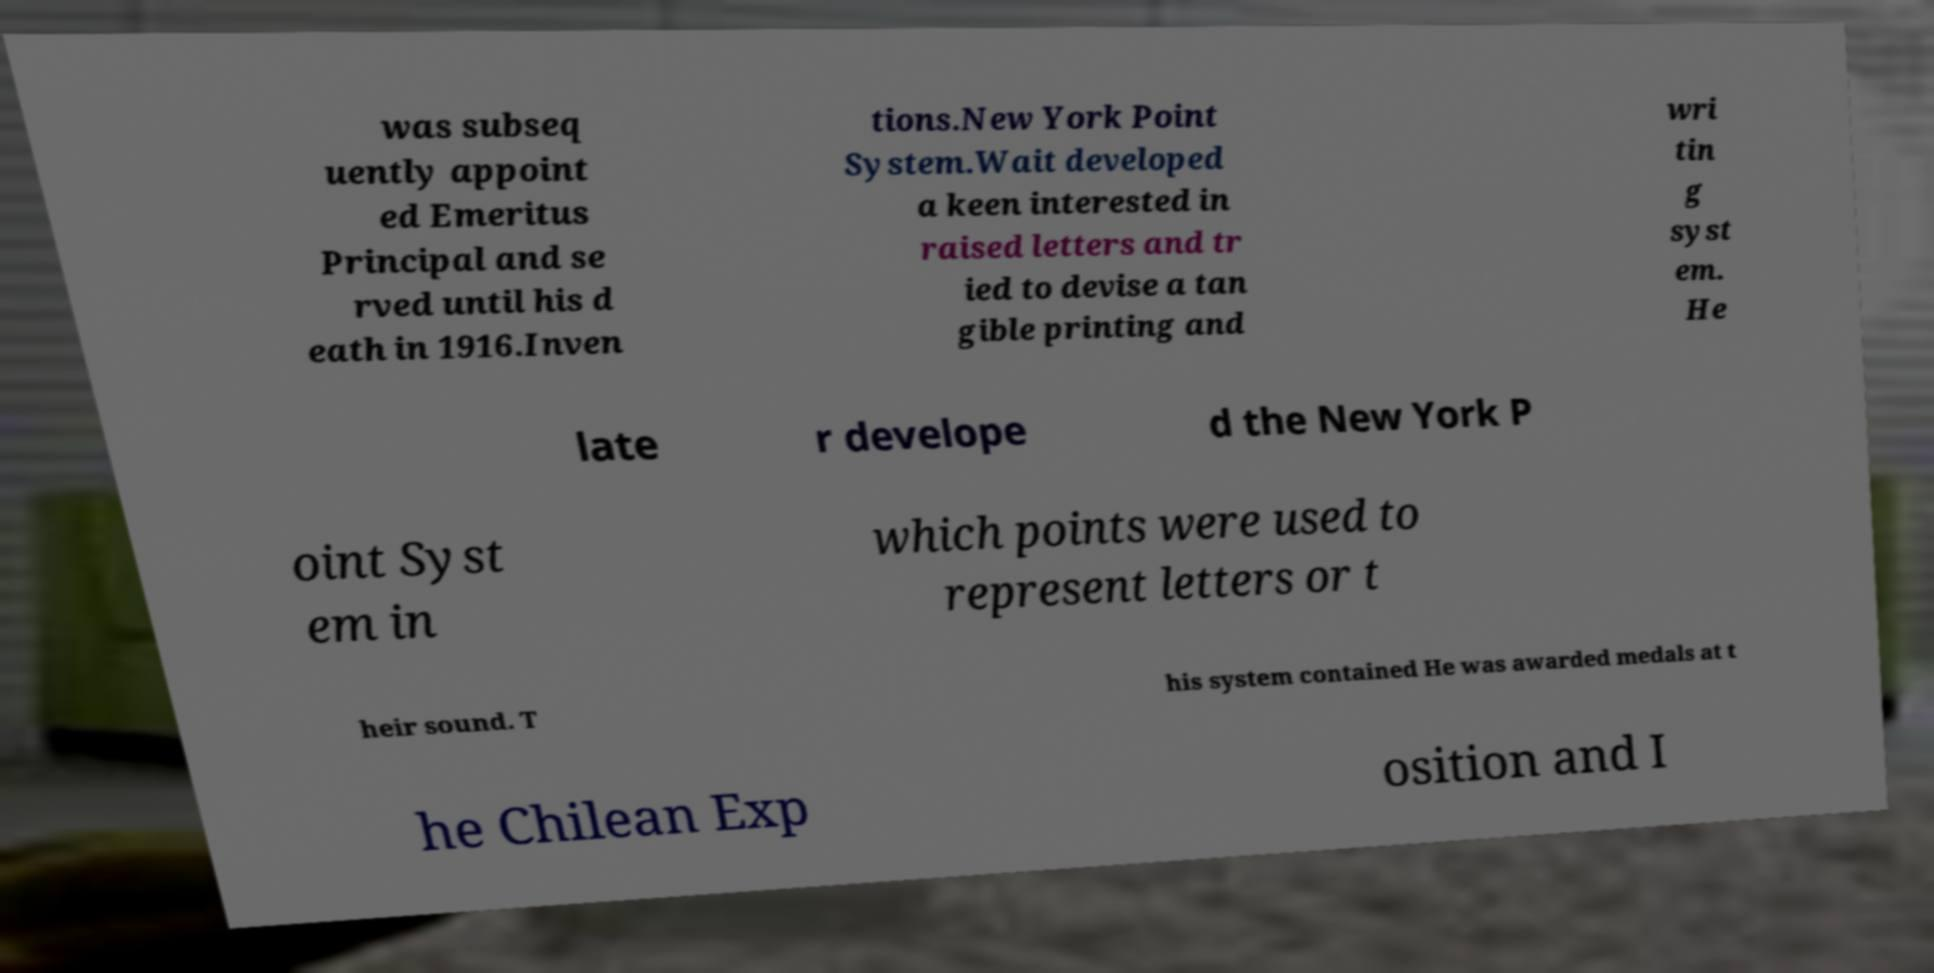Please read and relay the text visible in this image. What does it say? was subseq uently appoint ed Emeritus Principal and se rved until his d eath in 1916.Inven tions.New York Point System.Wait developed a keen interested in raised letters and tr ied to devise a tan gible printing and wri tin g syst em. He late r develope d the New York P oint Syst em in which points were used to represent letters or t heir sound. T his system contained He was awarded medals at t he Chilean Exp osition and I 